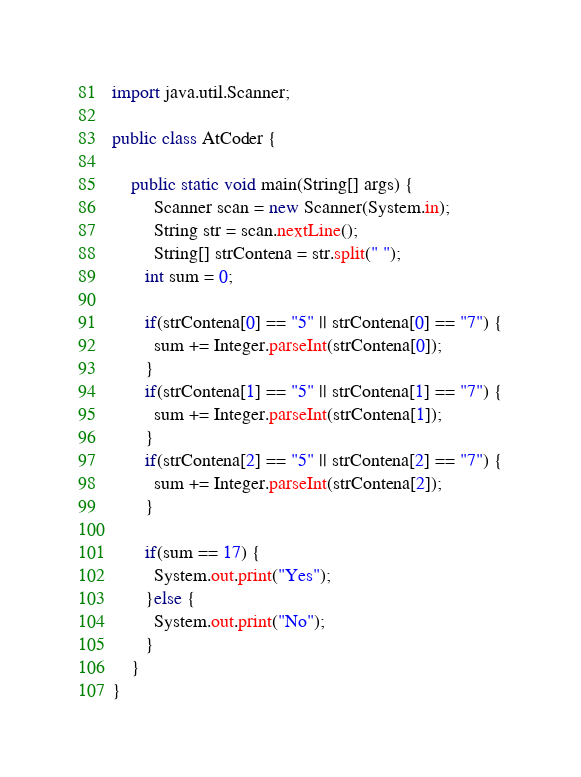<code> <loc_0><loc_0><loc_500><loc_500><_Java_>import java.util.Scanner;

public class AtCoder {

	public static void main(String[] args) {
		 Scanner scan = new Scanner(System.in);
		 String str = scan.nextLine();
		 String[] strContena = str.split(" ");
       int sum = 0;
       
       if(strContena[0] == "5" || strContena[0] == "7") {
      	 sum += Integer.parseInt(strContena[0]);
       }
       if(strContena[1] == "5" || strContena[1] == "7") {
      	 sum += Integer.parseInt(strContena[1]);
       }
       if(strContena[2] == "5" || strContena[2] == "7") {
      	 sum += Integer.parseInt(strContena[2]);
       }
       
       if(sum == 17) {
      	 System.out.print("Yes");
       }else {
      	 System.out.print("No");
       }
	}
}
</code> 